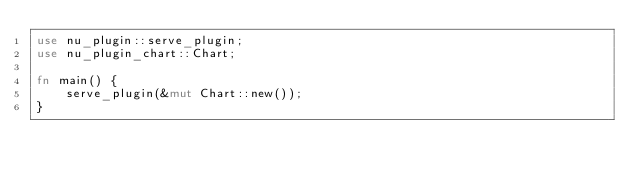<code> <loc_0><loc_0><loc_500><loc_500><_Rust_>use nu_plugin::serve_plugin;
use nu_plugin_chart::Chart;

fn main() {
    serve_plugin(&mut Chart::new());
}
</code> 